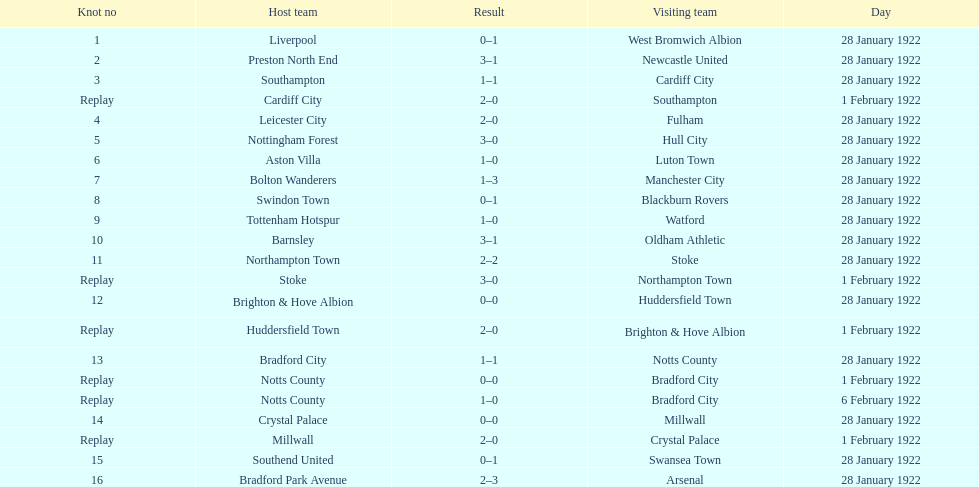When did they have a play before february 1? 28 January 1922. 